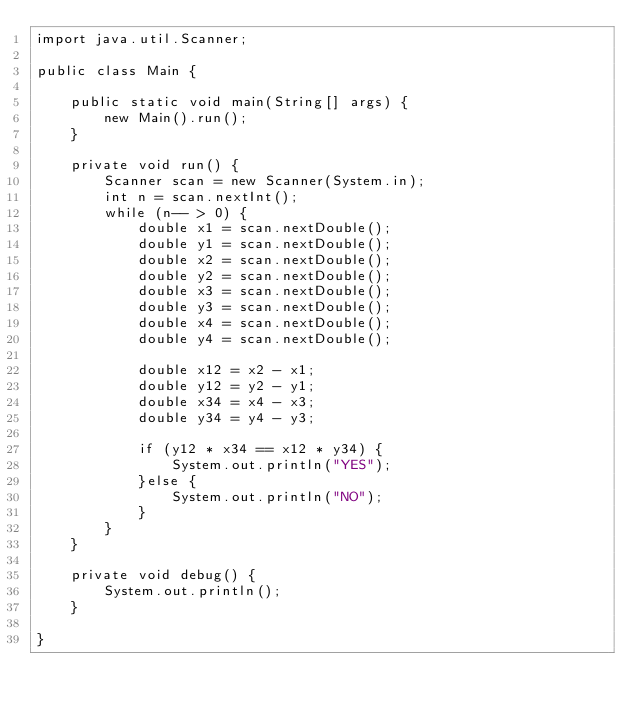<code> <loc_0><loc_0><loc_500><loc_500><_Java_>import java.util.Scanner;

public class Main {

	public static void main(String[] args) {
		new Main().run();
	}
	
	private void run() {
		Scanner scan = new Scanner(System.in);
		int n = scan.nextInt();
		while (n-- > 0) {
			double x1 = scan.nextDouble();
			double y1 = scan.nextDouble();
			double x2 = scan.nextDouble();
			double y2 = scan.nextDouble();
			double x3 = scan.nextDouble();
			double y3 = scan.nextDouble();
			double x4 = scan.nextDouble();
			double y4 = scan.nextDouble();
			
			double x12 = x2 - x1;
			double y12 = y2 - y1;
			double x34 = x4 - x3;
			double y34 = y4 - y3;
			
			if (y12 * x34 == x12 * y34) {
				System.out.println("YES");
			}else {
				System.out.println("NO");
			}
		}
	}
	
	private void debug() {
		System.out.println();
	}

}</code> 